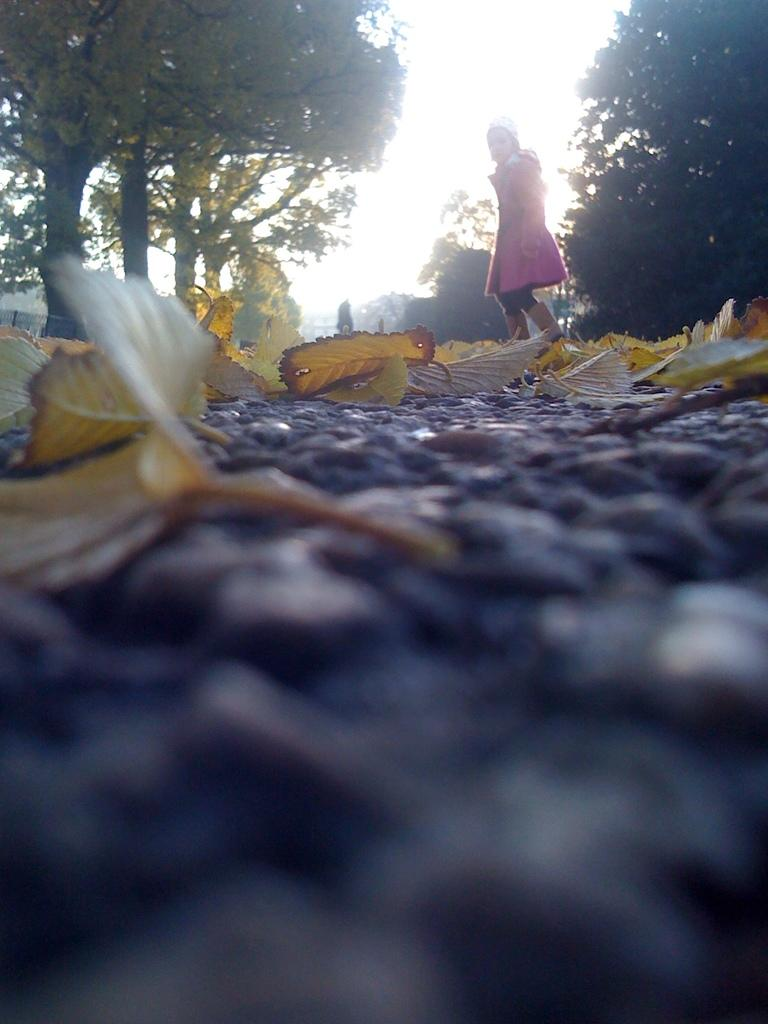What is on the ground in the image? There are dry leaves on the ground in the image. What can be seen in the foreground of the image? There is a girl standing on the ground in the image. What is visible in the background of the image? There are trees visible in the background of the image. How would you describe the clarity of the image? The image is blurred in the front. Can you see a ray of light touching the girl's hair in the image? There is no ray of light touching the girl's hair in the image. What type of ball is the girl holding in the image? There is no ball present in the image. 